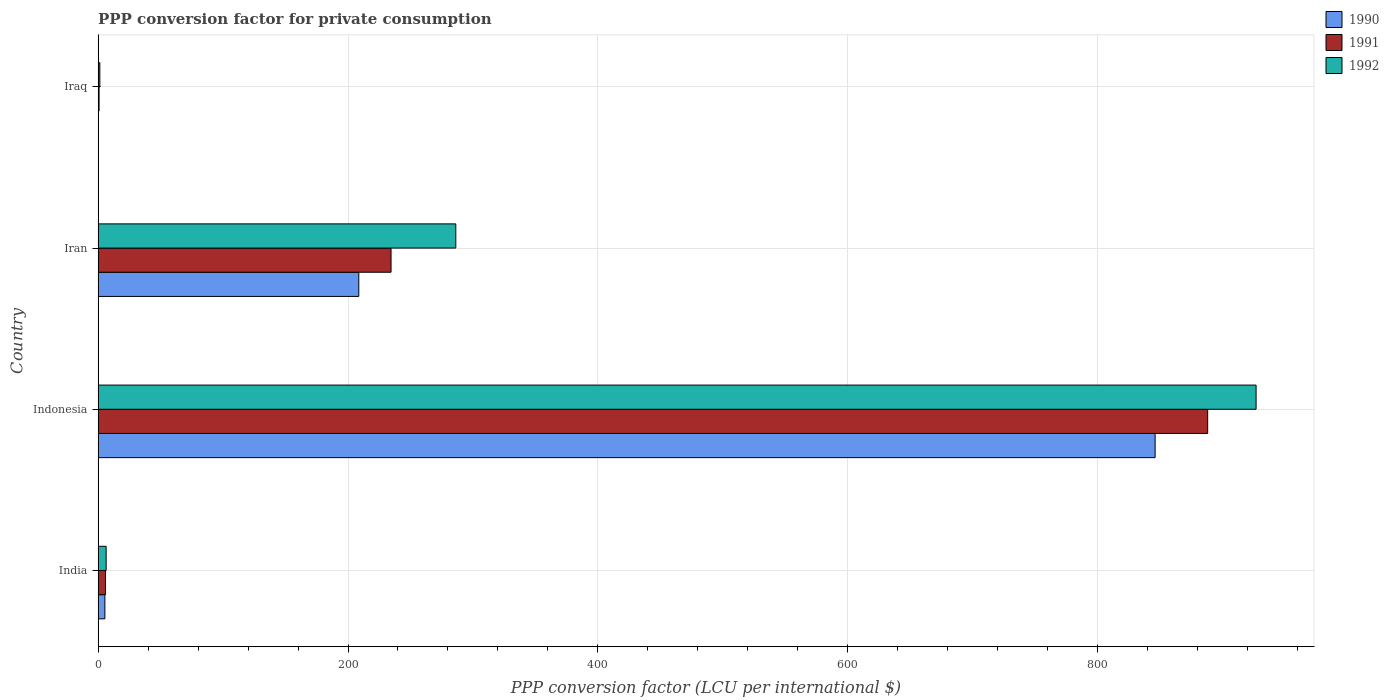How many different coloured bars are there?
Your response must be concise. 3. Are the number of bars per tick equal to the number of legend labels?
Your response must be concise. Yes. How many bars are there on the 4th tick from the top?
Provide a short and direct response. 3. How many bars are there on the 2nd tick from the bottom?
Your response must be concise. 3. What is the label of the 2nd group of bars from the top?
Your answer should be compact. Iran. What is the PPP conversion factor for private consumption in 1992 in Iraq?
Offer a terse response. 1.37. Across all countries, what is the maximum PPP conversion factor for private consumption in 1992?
Your answer should be compact. 926.82. Across all countries, what is the minimum PPP conversion factor for private consumption in 1992?
Your answer should be very brief. 1.37. In which country was the PPP conversion factor for private consumption in 1990 maximum?
Provide a short and direct response. Indonesia. In which country was the PPP conversion factor for private consumption in 1990 minimum?
Your answer should be very brief. Iraq. What is the total PPP conversion factor for private consumption in 1990 in the graph?
Provide a short and direct response. 1060.36. What is the difference between the PPP conversion factor for private consumption in 1991 in Indonesia and that in Iraq?
Keep it short and to the point. 887.29. What is the difference between the PPP conversion factor for private consumption in 1990 in India and the PPP conversion factor for private consumption in 1992 in Indonesia?
Provide a succinct answer. -921.41. What is the average PPP conversion factor for private consumption in 1992 per country?
Your response must be concise. 305.23. What is the difference between the PPP conversion factor for private consumption in 1991 and PPP conversion factor for private consumption in 1992 in Iraq?
Your answer should be compact. -0.6. In how many countries, is the PPP conversion factor for private consumption in 1992 greater than 160 LCU?
Give a very brief answer. 2. What is the ratio of the PPP conversion factor for private consumption in 1991 in Iran to that in Iraq?
Your answer should be compact. 304.98. What is the difference between the highest and the second highest PPP conversion factor for private consumption in 1990?
Keep it short and to the point. 637.36. What is the difference between the highest and the lowest PPP conversion factor for private consumption in 1992?
Your answer should be very brief. 925.45. What does the 1st bar from the top in Indonesia represents?
Offer a very short reply. 1992. What does the 3rd bar from the bottom in Indonesia represents?
Your response must be concise. 1992. Is it the case that in every country, the sum of the PPP conversion factor for private consumption in 1990 and PPP conversion factor for private consumption in 1991 is greater than the PPP conversion factor for private consumption in 1992?
Your response must be concise. No. How many bars are there?
Make the answer very short. 12. Does the graph contain grids?
Keep it short and to the point. Yes. How are the legend labels stacked?
Your answer should be very brief. Vertical. What is the title of the graph?
Your answer should be very brief. PPP conversion factor for private consumption. What is the label or title of the X-axis?
Your response must be concise. PPP conversion factor (LCU per international $). What is the PPP conversion factor (LCU per international $) of 1990 in India?
Give a very brief answer. 5.42. What is the PPP conversion factor (LCU per international $) in 1991 in India?
Ensure brevity in your answer.  5.92. What is the PPP conversion factor (LCU per international $) of 1992 in India?
Provide a short and direct response. 6.42. What is the PPP conversion factor (LCU per international $) of 1990 in Indonesia?
Keep it short and to the point. 846.01. What is the PPP conversion factor (LCU per international $) in 1991 in Indonesia?
Make the answer very short. 888.06. What is the PPP conversion factor (LCU per international $) of 1992 in Indonesia?
Your answer should be compact. 926.82. What is the PPP conversion factor (LCU per international $) in 1990 in Iran?
Make the answer very short. 208.65. What is the PPP conversion factor (LCU per international $) of 1991 in Iran?
Provide a succinct answer. 234.46. What is the PPP conversion factor (LCU per international $) of 1992 in Iran?
Keep it short and to the point. 286.29. What is the PPP conversion factor (LCU per international $) of 1990 in Iraq?
Keep it short and to the point. 0.29. What is the PPP conversion factor (LCU per international $) of 1991 in Iraq?
Give a very brief answer. 0.77. What is the PPP conversion factor (LCU per international $) in 1992 in Iraq?
Your response must be concise. 1.37. Across all countries, what is the maximum PPP conversion factor (LCU per international $) of 1990?
Provide a succinct answer. 846.01. Across all countries, what is the maximum PPP conversion factor (LCU per international $) of 1991?
Offer a terse response. 888.06. Across all countries, what is the maximum PPP conversion factor (LCU per international $) in 1992?
Your answer should be very brief. 926.82. Across all countries, what is the minimum PPP conversion factor (LCU per international $) in 1990?
Offer a very short reply. 0.29. Across all countries, what is the minimum PPP conversion factor (LCU per international $) of 1991?
Your answer should be compact. 0.77. Across all countries, what is the minimum PPP conversion factor (LCU per international $) in 1992?
Provide a short and direct response. 1.37. What is the total PPP conversion factor (LCU per international $) of 1990 in the graph?
Ensure brevity in your answer.  1060.36. What is the total PPP conversion factor (LCU per international $) of 1991 in the graph?
Give a very brief answer. 1129.21. What is the total PPP conversion factor (LCU per international $) of 1992 in the graph?
Make the answer very short. 1220.91. What is the difference between the PPP conversion factor (LCU per international $) of 1990 in India and that in Indonesia?
Offer a very short reply. -840.59. What is the difference between the PPP conversion factor (LCU per international $) of 1991 in India and that in Indonesia?
Your answer should be very brief. -882.15. What is the difference between the PPP conversion factor (LCU per international $) in 1992 in India and that in Indonesia?
Make the answer very short. -920.4. What is the difference between the PPP conversion factor (LCU per international $) of 1990 in India and that in Iran?
Offer a very short reply. -203.23. What is the difference between the PPP conversion factor (LCU per international $) in 1991 in India and that in Iran?
Provide a short and direct response. -228.54. What is the difference between the PPP conversion factor (LCU per international $) of 1992 in India and that in Iran?
Offer a very short reply. -279.87. What is the difference between the PPP conversion factor (LCU per international $) in 1990 in India and that in Iraq?
Provide a short and direct response. 5.13. What is the difference between the PPP conversion factor (LCU per international $) of 1991 in India and that in Iraq?
Offer a very short reply. 5.15. What is the difference between the PPP conversion factor (LCU per international $) of 1992 in India and that in Iraq?
Make the answer very short. 5.05. What is the difference between the PPP conversion factor (LCU per international $) in 1990 in Indonesia and that in Iran?
Make the answer very short. 637.36. What is the difference between the PPP conversion factor (LCU per international $) in 1991 in Indonesia and that in Iran?
Make the answer very short. 653.61. What is the difference between the PPP conversion factor (LCU per international $) in 1992 in Indonesia and that in Iran?
Your answer should be compact. 640.53. What is the difference between the PPP conversion factor (LCU per international $) of 1990 in Indonesia and that in Iraq?
Ensure brevity in your answer.  845.73. What is the difference between the PPP conversion factor (LCU per international $) of 1991 in Indonesia and that in Iraq?
Your answer should be very brief. 887.29. What is the difference between the PPP conversion factor (LCU per international $) in 1992 in Indonesia and that in Iraq?
Your response must be concise. 925.45. What is the difference between the PPP conversion factor (LCU per international $) in 1990 in Iran and that in Iraq?
Ensure brevity in your answer.  208.36. What is the difference between the PPP conversion factor (LCU per international $) of 1991 in Iran and that in Iraq?
Ensure brevity in your answer.  233.69. What is the difference between the PPP conversion factor (LCU per international $) of 1992 in Iran and that in Iraq?
Offer a terse response. 284.92. What is the difference between the PPP conversion factor (LCU per international $) of 1990 in India and the PPP conversion factor (LCU per international $) of 1991 in Indonesia?
Ensure brevity in your answer.  -882.65. What is the difference between the PPP conversion factor (LCU per international $) of 1990 in India and the PPP conversion factor (LCU per international $) of 1992 in Indonesia?
Offer a terse response. -921.41. What is the difference between the PPP conversion factor (LCU per international $) of 1991 in India and the PPP conversion factor (LCU per international $) of 1992 in Indonesia?
Keep it short and to the point. -920.91. What is the difference between the PPP conversion factor (LCU per international $) in 1990 in India and the PPP conversion factor (LCU per international $) in 1991 in Iran?
Make the answer very short. -229.04. What is the difference between the PPP conversion factor (LCU per international $) in 1990 in India and the PPP conversion factor (LCU per international $) in 1992 in Iran?
Keep it short and to the point. -280.87. What is the difference between the PPP conversion factor (LCU per international $) of 1991 in India and the PPP conversion factor (LCU per international $) of 1992 in Iran?
Keep it short and to the point. -280.37. What is the difference between the PPP conversion factor (LCU per international $) in 1990 in India and the PPP conversion factor (LCU per international $) in 1991 in Iraq?
Keep it short and to the point. 4.65. What is the difference between the PPP conversion factor (LCU per international $) of 1990 in India and the PPP conversion factor (LCU per international $) of 1992 in Iraq?
Provide a succinct answer. 4.05. What is the difference between the PPP conversion factor (LCU per international $) of 1991 in India and the PPP conversion factor (LCU per international $) of 1992 in Iraq?
Your answer should be compact. 4.55. What is the difference between the PPP conversion factor (LCU per international $) in 1990 in Indonesia and the PPP conversion factor (LCU per international $) in 1991 in Iran?
Your response must be concise. 611.56. What is the difference between the PPP conversion factor (LCU per international $) in 1990 in Indonesia and the PPP conversion factor (LCU per international $) in 1992 in Iran?
Keep it short and to the point. 559.72. What is the difference between the PPP conversion factor (LCU per international $) of 1991 in Indonesia and the PPP conversion factor (LCU per international $) of 1992 in Iran?
Offer a very short reply. 601.77. What is the difference between the PPP conversion factor (LCU per international $) of 1990 in Indonesia and the PPP conversion factor (LCU per international $) of 1991 in Iraq?
Offer a very short reply. 845.24. What is the difference between the PPP conversion factor (LCU per international $) of 1990 in Indonesia and the PPP conversion factor (LCU per international $) of 1992 in Iraq?
Your answer should be very brief. 844.64. What is the difference between the PPP conversion factor (LCU per international $) in 1991 in Indonesia and the PPP conversion factor (LCU per international $) in 1992 in Iraq?
Keep it short and to the point. 886.69. What is the difference between the PPP conversion factor (LCU per international $) in 1990 in Iran and the PPP conversion factor (LCU per international $) in 1991 in Iraq?
Offer a terse response. 207.88. What is the difference between the PPP conversion factor (LCU per international $) in 1990 in Iran and the PPP conversion factor (LCU per international $) in 1992 in Iraq?
Your response must be concise. 207.28. What is the difference between the PPP conversion factor (LCU per international $) in 1991 in Iran and the PPP conversion factor (LCU per international $) in 1992 in Iraq?
Offer a terse response. 233.09. What is the average PPP conversion factor (LCU per international $) of 1990 per country?
Make the answer very short. 265.09. What is the average PPP conversion factor (LCU per international $) of 1991 per country?
Offer a very short reply. 282.3. What is the average PPP conversion factor (LCU per international $) of 1992 per country?
Make the answer very short. 305.23. What is the difference between the PPP conversion factor (LCU per international $) in 1990 and PPP conversion factor (LCU per international $) in 1991 in India?
Provide a short and direct response. -0.5. What is the difference between the PPP conversion factor (LCU per international $) of 1990 and PPP conversion factor (LCU per international $) of 1992 in India?
Make the answer very short. -1. What is the difference between the PPP conversion factor (LCU per international $) of 1991 and PPP conversion factor (LCU per international $) of 1992 in India?
Offer a terse response. -0.5. What is the difference between the PPP conversion factor (LCU per international $) of 1990 and PPP conversion factor (LCU per international $) of 1991 in Indonesia?
Offer a terse response. -42.05. What is the difference between the PPP conversion factor (LCU per international $) of 1990 and PPP conversion factor (LCU per international $) of 1992 in Indonesia?
Provide a short and direct response. -80.81. What is the difference between the PPP conversion factor (LCU per international $) in 1991 and PPP conversion factor (LCU per international $) in 1992 in Indonesia?
Provide a succinct answer. -38.76. What is the difference between the PPP conversion factor (LCU per international $) of 1990 and PPP conversion factor (LCU per international $) of 1991 in Iran?
Make the answer very short. -25.81. What is the difference between the PPP conversion factor (LCU per international $) in 1990 and PPP conversion factor (LCU per international $) in 1992 in Iran?
Provide a short and direct response. -77.65. What is the difference between the PPP conversion factor (LCU per international $) of 1991 and PPP conversion factor (LCU per international $) of 1992 in Iran?
Your response must be concise. -51.84. What is the difference between the PPP conversion factor (LCU per international $) in 1990 and PPP conversion factor (LCU per international $) in 1991 in Iraq?
Ensure brevity in your answer.  -0.48. What is the difference between the PPP conversion factor (LCU per international $) of 1990 and PPP conversion factor (LCU per international $) of 1992 in Iraq?
Offer a very short reply. -1.08. What is the difference between the PPP conversion factor (LCU per international $) of 1991 and PPP conversion factor (LCU per international $) of 1992 in Iraq?
Your response must be concise. -0.6. What is the ratio of the PPP conversion factor (LCU per international $) in 1990 in India to that in Indonesia?
Your answer should be compact. 0.01. What is the ratio of the PPP conversion factor (LCU per international $) in 1991 in India to that in Indonesia?
Your response must be concise. 0.01. What is the ratio of the PPP conversion factor (LCU per international $) of 1992 in India to that in Indonesia?
Offer a terse response. 0.01. What is the ratio of the PPP conversion factor (LCU per international $) in 1990 in India to that in Iran?
Offer a very short reply. 0.03. What is the ratio of the PPP conversion factor (LCU per international $) in 1991 in India to that in Iran?
Make the answer very short. 0.03. What is the ratio of the PPP conversion factor (LCU per international $) in 1992 in India to that in Iran?
Give a very brief answer. 0.02. What is the ratio of the PPP conversion factor (LCU per international $) in 1990 in India to that in Iraq?
Your response must be concise. 18.99. What is the ratio of the PPP conversion factor (LCU per international $) of 1991 in India to that in Iraq?
Your response must be concise. 7.7. What is the ratio of the PPP conversion factor (LCU per international $) in 1992 in India to that in Iraq?
Offer a terse response. 4.69. What is the ratio of the PPP conversion factor (LCU per international $) of 1990 in Indonesia to that in Iran?
Provide a short and direct response. 4.05. What is the ratio of the PPP conversion factor (LCU per international $) in 1991 in Indonesia to that in Iran?
Provide a succinct answer. 3.79. What is the ratio of the PPP conversion factor (LCU per international $) of 1992 in Indonesia to that in Iran?
Provide a short and direct response. 3.24. What is the ratio of the PPP conversion factor (LCU per international $) of 1990 in Indonesia to that in Iraq?
Keep it short and to the point. 2966.25. What is the ratio of the PPP conversion factor (LCU per international $) in 1991 in Indonesia to that in Iraq?
Provide a short and direct response. 1155.2. What is the ratio of the PPP conversion factor (LCU per international $) in 1992 in Indonesia to that in Iraq?
Your answer should be very brief. 676.49. What is the ratio of the PPP conversion factor (LCU per international $) of 1990 in Iran to that in Iraq?
Make the answer very short. 731.55. What is the ratio of the PPP conversion factor (LCU per international $) in 1991 in Iran to that in Iraq?
Your answer should be very brief. 304.98. What is the ratio of the PPP conversion factor (LCU per international $) of 1992 in Iran to that in Iraq?
Provide a short and direct response. 208.96. What is the difference between the highest and the second highest PPP conversion factor (LCU per international $) of 1990?
Keep it short and to the point. 637.36. What is the difference between the highest and the second highest PPP conversion factor (LCU per international $) in 1991?
Offer a very short reply. 653.61. What is the difference between the highest and the second highest PPP conversion factor (LCU per international $) in 1992?
Provide a short and direct response. 640.53. What is the difference between the highest and the lowest PPP conversion factor (LCU per international $) of 1990?
Keep it short and to the point. 845.73. What is the difference between the highest and the lowest PPP conversion factor (LCU per international $) in 1991?
Give a very brief answer. 887.29. What is the difference between the highest and the lowest PPP conversion factor (LCU per international $) in 1992?
Make the answer very short. 925.45. 